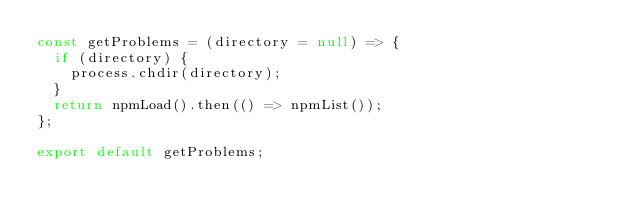<code> <loc_0><loc_0><loc_500><loc_500><_JavaScript_>const getProblems = (directory = null) => {
  if (directory) {
    process.chdir(directory);
  }
  return npmLoad().then(() => npmList());
};

export default getProblems;
</code> 